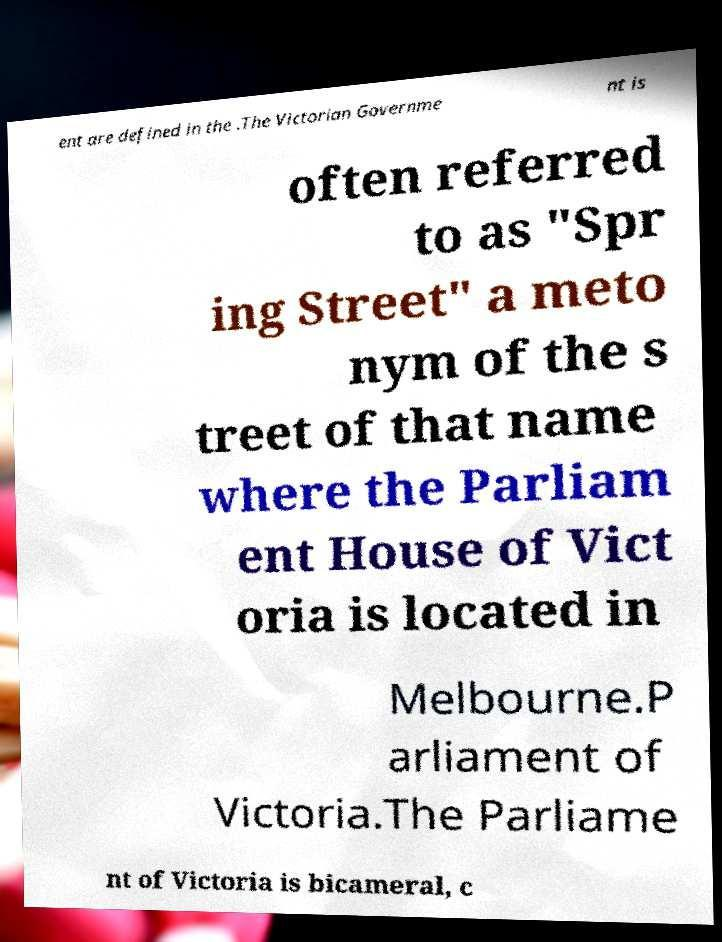What messages or text are displayed in this image? I need them in a readable, typed format. ent are defined in the .The Victorian Governme nt is often referred to as "Spr ing Street" a meto nym of the s treet of that name where the Parliam ent House of Vict oria is located in Melbourne.P arliament of Victoria.The Parliame nt of Victoria is bicameral, c 